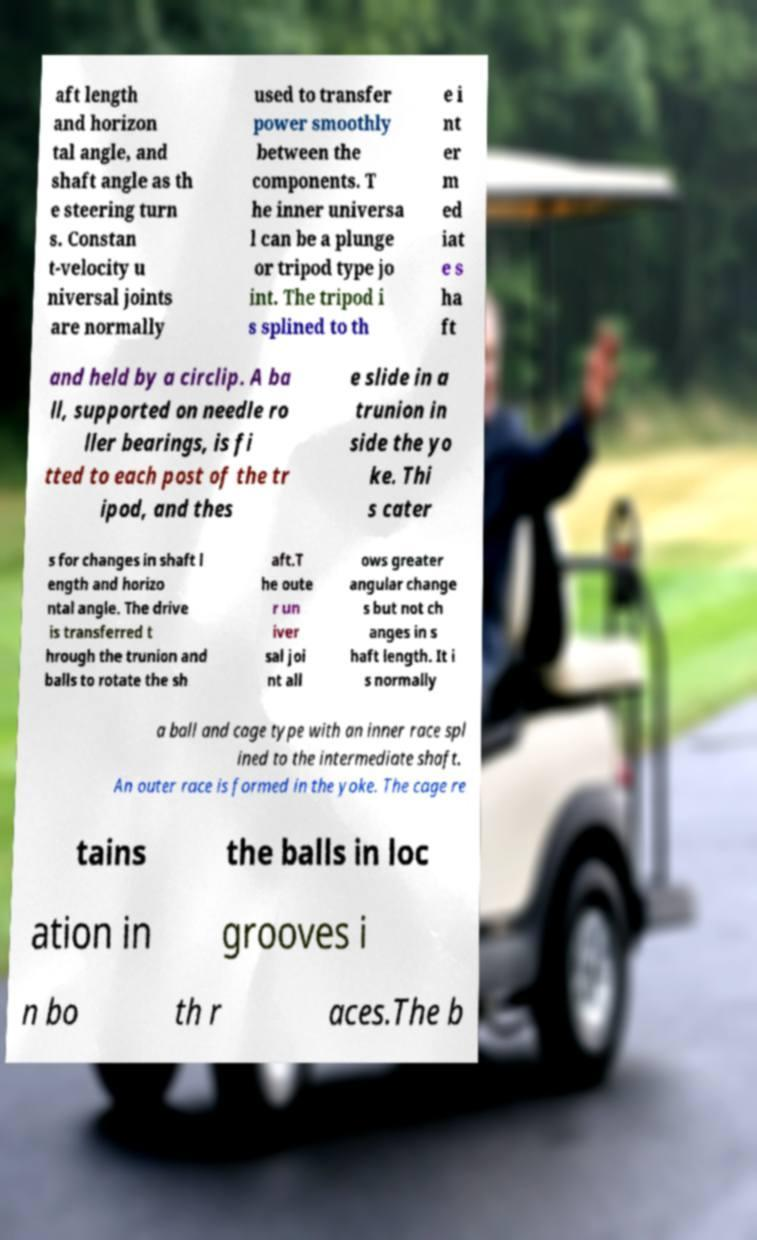Can you read and provide the text displayed in the image?This photo seems to have some interesting text. Can you extract and type it out for me? aft length and horizon tal angle, and shaft angle as th e steering turn s. Constan t-velocity u niversal joints are normally used to transfer power smoothly between the components. T he inner universa l can be a plunge or tripod type jo int. The tripod i s splined to th e i nt er m ed iat e s ha ft and held by a circlip. A ba ll, supported on needle ro ller bearings, is fi tted to each post of the tr ipod, and thes e slide in a trunion in side the yo ke. Thi s cater s for changes in shaft l ength and horizo ntal angle. The drive is transferred t hrough the trunion and balls to rotate the sh aft.T he oute r un iver sal joi nt all ows greater angular change s but not ch anges in s haft length. It i s normally a ball and cage type with an inner race spl ined to the intermediate shaft. An outer race is formed in the yoke. The cage re tains the balls in loc ation in grooves i n bo th r aces.The b 